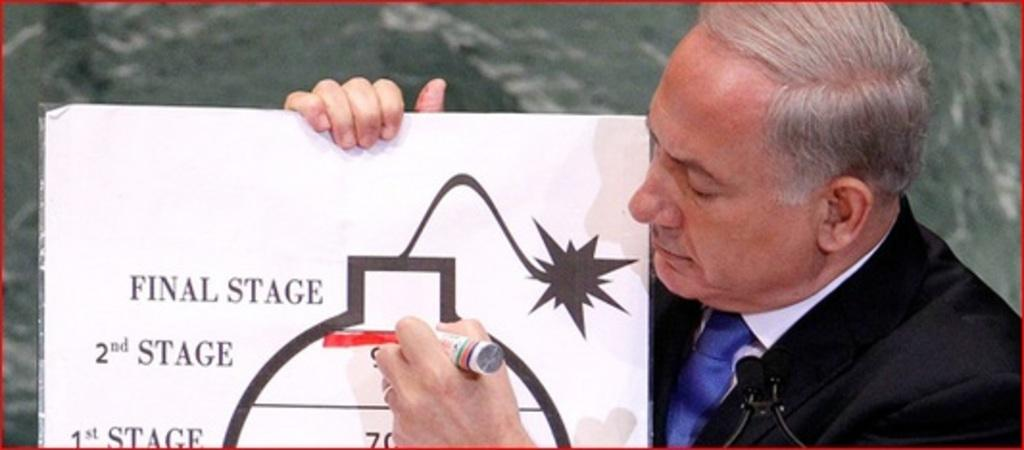What is the man in the image wearing? The man is wearing a black suit. What is the man holding in his hand? The man is holding a microphone and a board. What is the purpose of the marker in the image? The marker is likely used for writing on the board. What can be seen written on the board? There are words written on the board. How many ants can be seen crawling on the man's suit in the image? There are no ants visible in the image. Can you tell me how much eggnog the man is holding in the image? There is no eggnog present in the image. 